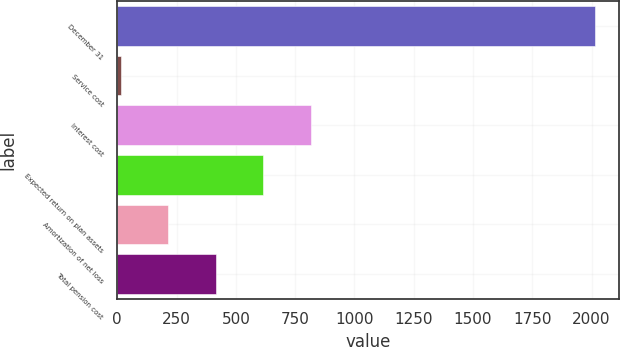<chart> <loc_0><loc_0><loc_500><loc_500><bar_chart><fcel>December 31<fcel>Service cost<fcel>Interest cost<fcel>Expected return on plan assets<fcel>Amortization of net loss<fcel>Total pension cost<nl><fcel>2014<fcel>16<fcel>815.2<fcel>615.4<fcel>215.8<fcel>415.6<nl></chart> 